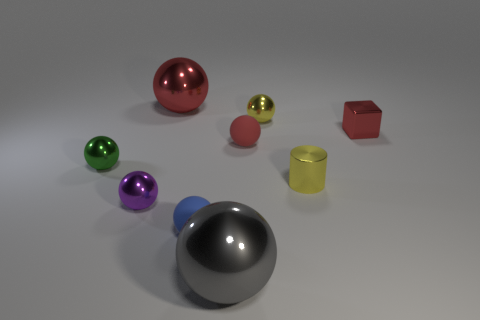Subtract all green spheres. How many spheres are left? 6 Subtract all blue matte spheres. How many spheres are left? 6 Subtract all gray balls. Subtract all brown cubes. How many balls are left? 6 Add 1 big gray things. How many objects exist? 10 Subtract all blocks. How many objects are left? 8 Add 9 red rubber balls. How many red rubber balls are left? 10 Add 4 tiny shiny things. How many tiny shiny things exist? 9 Subtract 1 purple balls. How many objects are left? 8 Subtract all tiny red things. Subtract all purple spheres. How many objects are left? 6 